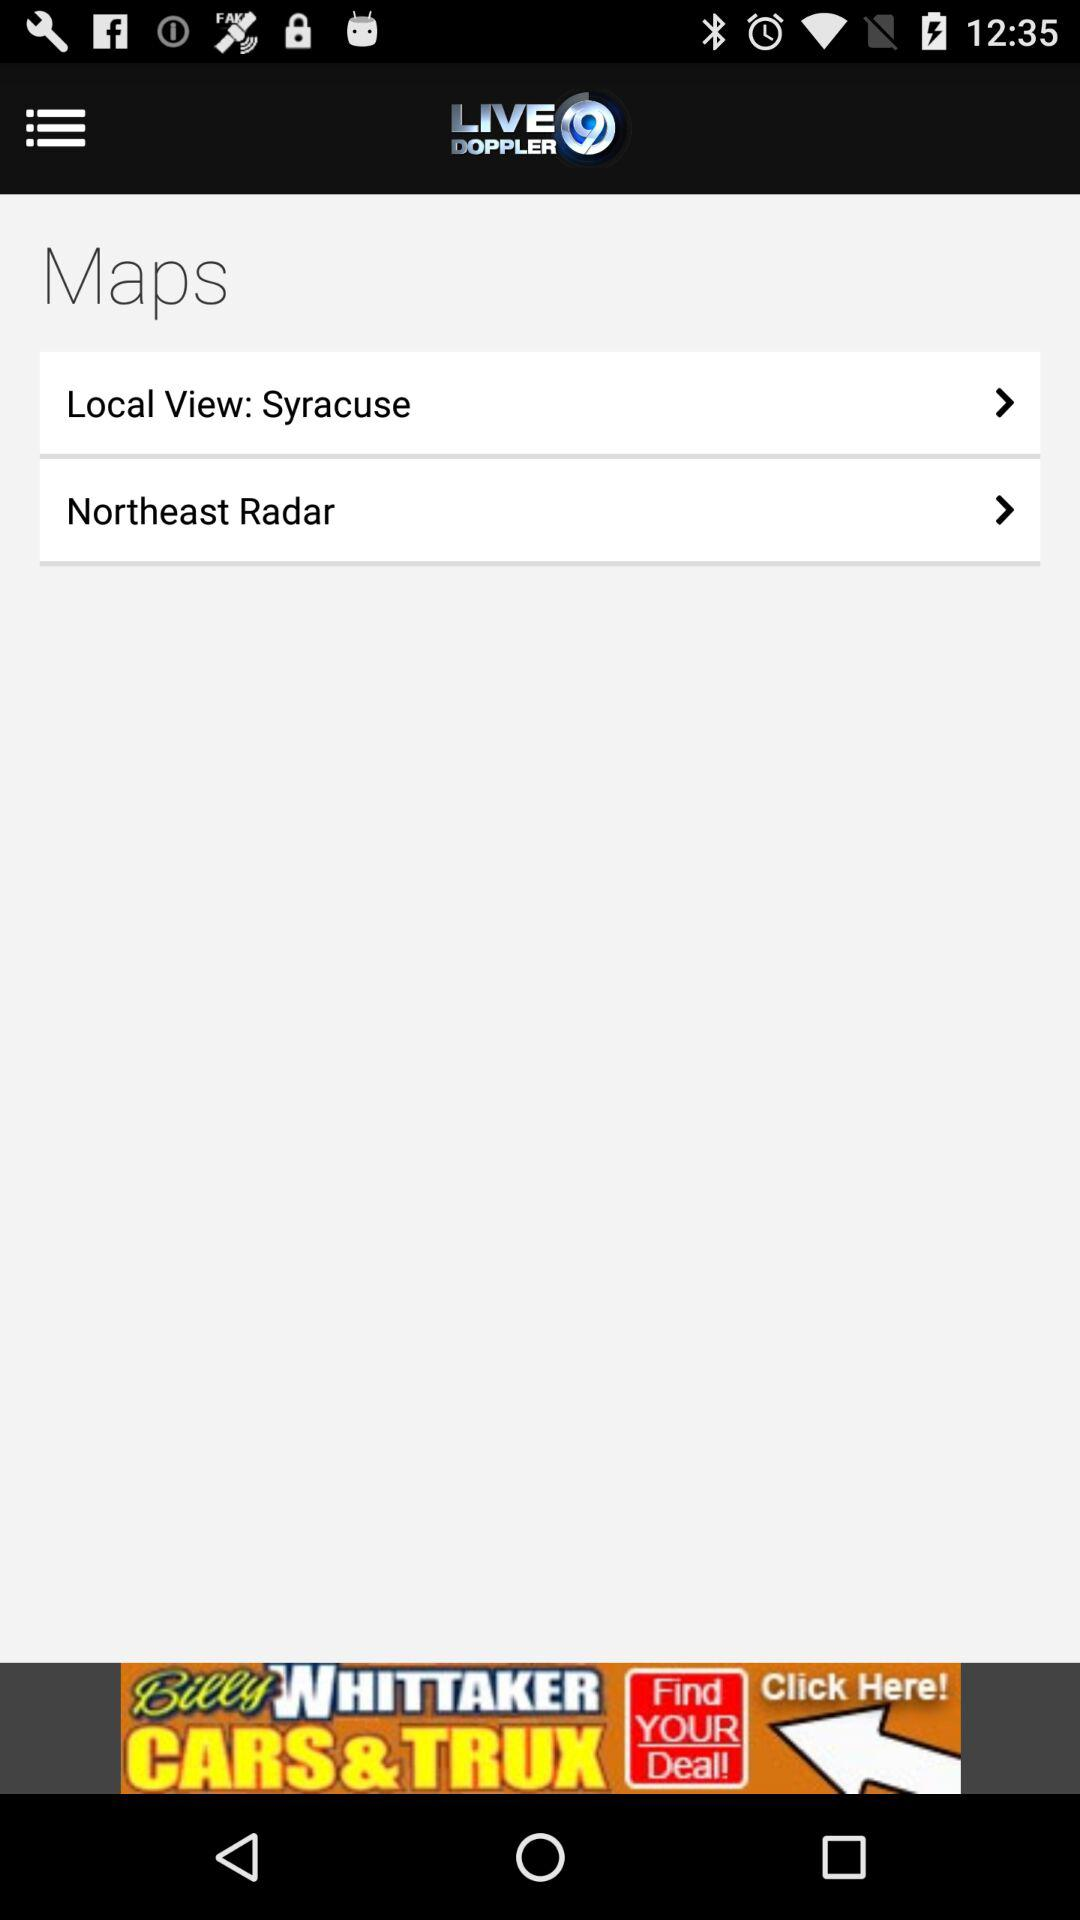What is the name of the application? The name of the application is "WSYR LiveDoppler9 LocalSYR". 